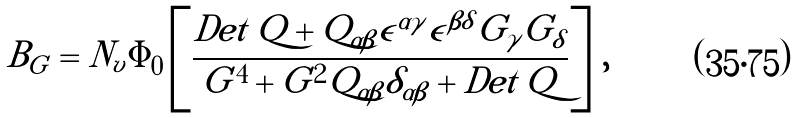<formula> <loc_0><loc_0><loc_500><loc_500>B _ { G } = N _ { v } \Phi _ { 0 } \left [ \frac { D e t \, Q + Q _ { \alpha \beta } \epsilon ^ { \alpha \gamma } \epsilon ^ { \beta \delta } G _ { \gamma } G _ { \delta } } { G ^ { 4 } + G ^ { 2 } Q _ { \alpha \beta } \delta _ { \alpha \beta } + D e t \, Q } \right ] \, ,</formula> 